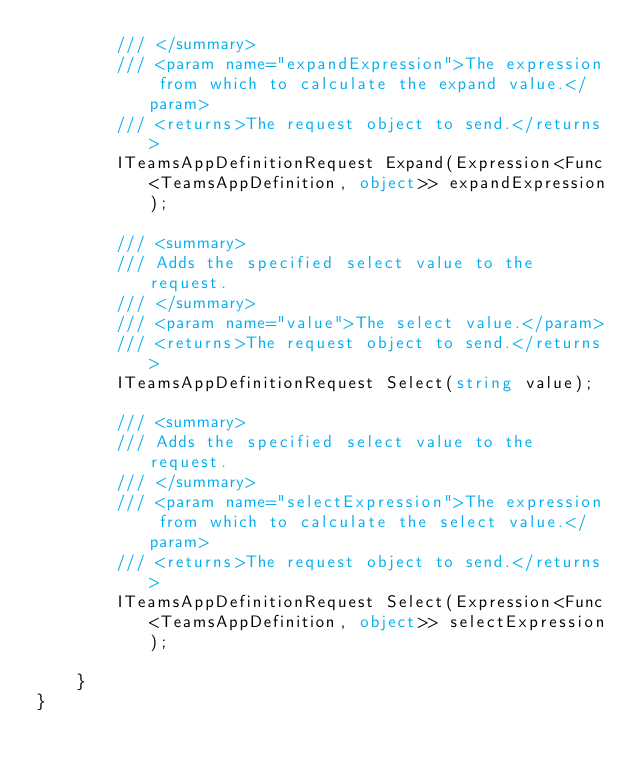<code> <loc_0><loc_0><loc_500><loc_500><_C#_>        /// </summary>
        /// <param name="expandExpression">The expression from which to calculate the expand value.</param>
        /// <returns>The request object to send.</returns>
        ITeamsAppDefinitionRequest Expand(Expression<Func<TeamsAppDefinition, object>> expandExpression);

        /// <summary>
        /// Adds the specified select value to the request.
        /// </summary>
        /// <param name="value">The select value.</param>
        /// <returns>The request object to send.</returns>
        ITeamsAppDefinitionRequest Select(string value);

        /// <summary>
        /// Adds the specified select value to the request.
        /// </summary>
        /// <param name="selectExpression">The expression from which to calculate the select value.</param>
        /// <returns>The request object to send.</returns>
        ITeamsAppDefinitionRequest Select(Expression<Func<TeamsAppDefinition, object>> selectExpression);

    }
}
</code> 